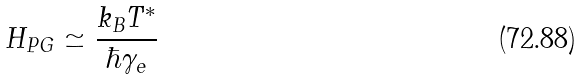<formula> <loc_0><loc_0><loc_500><loc_500>H _ { P G } \simeq \frac { k _ { B } T ^ { * } } { \hbar { \gamma } _ { e } }</formula> 